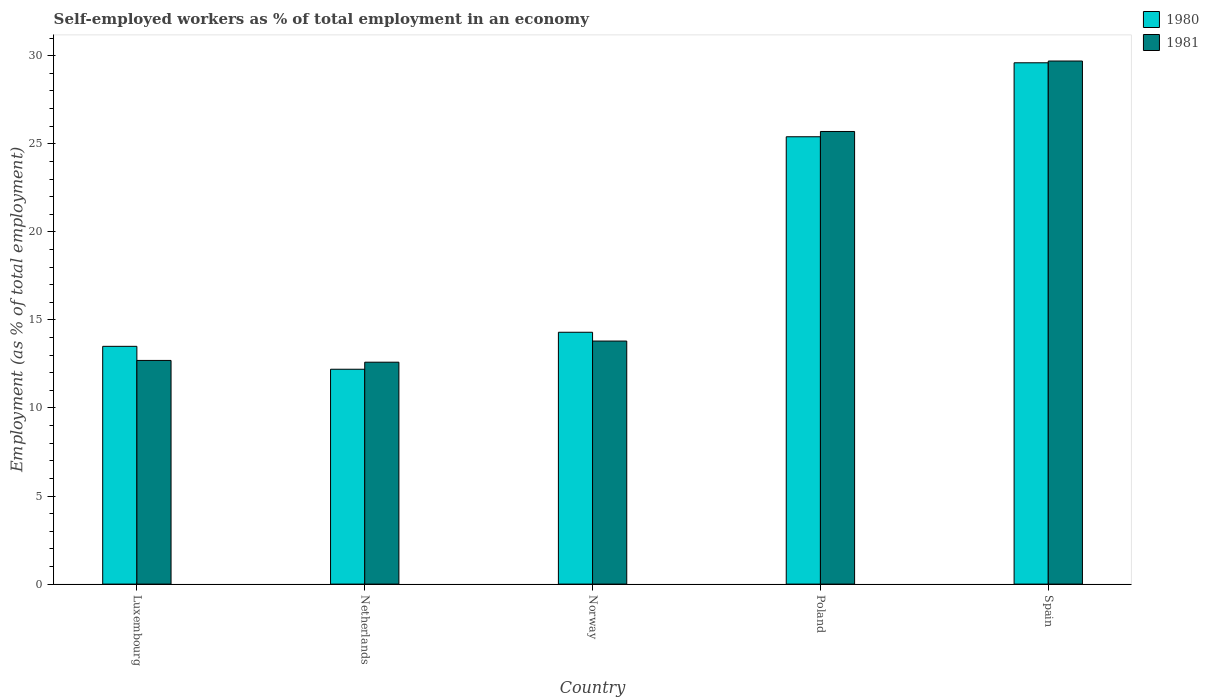How many groups of bars are there?
Your response must be concise. 5. Are the number of bars per tick equal to the number of legend labels?
Offer a terse response. Yes. How many bars are there on the 5th tick from the right?
Your answer should be compact. 2. What is the label of the 5th group of bars from the left?
Make the answer very short. Spain. What is the percentage of self-employed workers in 1981 in Netherlands?
Your response must be concise. 12.6. Across all countries, what is the maximum percentage of self-employed workers in 1980?
Your response must be concise. 29.6. Across all countries, what is the minimum percentage of self-employed workers in 1980?
Offer a very short reply. 12.2. In which country was the percentage of self-employed workers in 1981 maximum?
Provide a short and direct response. Spain. What is the total percentage of self-employed workers in 1980 in the graph?
Your response must be concise. 95. What is the difference between the percentage of self-employed workers in 1980 in Netherlands and that in Poland?
Your answer should be compact. -13.2. What is the difference between the percentage of self-employed workers in 1980 in Netherlands and the percentage of self-employed workers in 1981 in Norway?
Offer a terse response. -1.6. What is the difference between the percentage of self-employed workers of/in 1981 and percentage of self-employed workers of/in 1980 in Spain?
Offer a very short reply. 0.1. What is the ratio of the percentage of self-employed workers in 1981 in Norway to that in Spain?
Your response must be concise. 0.46. What is the difference between the highest and the second highest percentage of self-employed workers in 1980?
Provide a succinct answer. -4.2. What is the difference between the highest and the lowest percentage of self-employed workers in 1981?
Ensure brevity in your answer.  17.1. What does the 1st bar from the left in Luxembourg represents?
Provide a short and direct response. 1980. How many countries are there in the graph?
Provide a short and direct response. 5. What is the difference between two consecutive major ticks on the Y-axis?
Make the answer very short. 5. Are the values on the major ticks of Y-axis written in scientific E-notation?
Give a very brief answer. No. Where does the legend appear in the graph?
Offer a terse response. Top right. How many legend labels are there?
Provide a succinct answer. 2. How are the legend labels stacked?
Make the answer very short. Vertical. What is the title of the graph?
Offer a very short reply. Self-employed workers as % of total employment in an economy. What is the label or title of the X-axis?
Offer a very short reply. Country. What is the label or title of the Y-axis?
Keep it short and to the point. Employment (as % of total employment). What is the Employment (as % of total employment) in 1981 in Luxembourg?
Provide a succinct answer. 12.7. What is the Employment (as % of total employment) of 1980 in Netherlands?
Give a very brief answer. 12.2. What is the Employment (as % of total employment) in 1981 in Netherlands?
Keep it short and to the point. 12.6. What is the Employment (as % of total employment) in 1980 in Norway?
Your response must be concise. 14.3. What is the Employment (as % of total employment) in 1981 in Norway?
Make the answer very short. 13.8. What is the Employment (as % of total employment) of 1980 in Poland?
Offer a very short reply. 25.4. What is the Employment (as % of total employment) of 1981 in Poland?
Keep it short and to the point. 25.7. What is the Employment (as % of total employment) of 1980 in Spain?
Keep it short and to the point. 29.6. What is the Employment (as % of total employment) in 1981 in Spain?
Ensure brevity in your answer.  29.7. Across all countries, what is the maximum Employment (as % of total employment) in 1980?
Give a very brief answer. 29.6. Across all countries, what is the maximum Employment (as % of total employment) of 1981?
Offer a terse response. 29.7. Across all countries, what is the minimum Employment (as % of total employment) of 1980?
Make the answer very short. 12.2. Across all countries, what is the minimum Employment (as % of total employment) in 1981?
Provide a succinct answer. 12.6. What is the total Employment (as % of total employment) of 1981 in the graph?
Provide a short and direct response. 94.5. What is the difference between the Employment (as % of total employment) in 1981 in Luxembourg and that in Netherlands?
Give a very brief answer. 0.1. What is the difference between the Employment (as % of total employment) of 1980 in Luxembourg and that in Norway?
Provide a short and direct response. -0.8. What is the difference between the Employment (as % of total employment) of 1980 in Luxembourg and that in Spain?
Provide a short and direct response. -16.1. What is the difference between the Employment (as % of total employment) of 1981 in Luxembourg and that in Spain?
Your answer should be compact. -17. What is the difference between the Employment (as % of total employment) in 1980 in Netherlands and that in Poland?
Keep it short and to the point. -13.2. What is the difference between the Employment (as % of total employment) in 1980 in Netherlands and that in Spain?
Your answer should be compact. -17.4. What is the difference between the Employment (as % of total employment) in 1981 in Netherlands and that in Spain?
Give a very brief answer. -17.1. What is the difference between the Employment (as % of total employment) in 1980 in Norway and that in Poland?
Offer a terse response. -11.1. What is the difference between the Employment (as % of total employment) in 1980 in Norway and that in Spain?
Your response must be concise. -15.3. What is the difference between the Employment (as % of total employment) in 1981 in Norway and that in Spain?
Provide a succinct answer. -15.9. What is the difference between the Employment (as % of total employment) in 1981 in Poland and that in Spain?
Your response must be concise. -4. What is the difference between the Employment (as % of total employment) in 1980 in Luxembourg and the Employment (as % of total employment) in 1981 in Netherlands?
Ensure brevity in your answer.  0.9. What is the difference between the Employment (as % of total employment) in 1980 in Luxembourg and the Employment (as % of total employment) in 1981 in Norway?
Offer a terse response. -0.3. What is the difference between the Employment (as % of total employment) in 1980 in Luxembourg and the Employment (as % of total employment) in 1981 in Poland?
Your answer should be very brief. -12.2. What is the difference between the Employment (as % of total employment) in 1980 in Luxembourg and the Employment (as % of total employment) in 1981 in Spain?
Your answer should be very brief. -16.2. What is the difference between the Employment (as % of total employment) in 1980 in Netherlands and the Employment (as % of total employment) in 1981 in Poland?
Your answer should be very brief. -13.5. What is the difference between the Employment (as % of total employment) in 1980 in Netherlands and the Employment (as % of total employment) in 1981 in Spain?
Provide a succinct answer. -17.5. What is the difference between the Employment (as % of total employment) of 1980 in Norway and the Employment (as % of total employment) of 1981 in Poland?
Make the answer very short. -11.4. What is the difference between the Employment (as % of total employment) in 1980 in Norway and the Employment (as % of total employment) in 1981 in Spain?
Offer a terse response. -15.4. What is the difference between the Employment (as % of total employment) in 1980 and Employment (as % of total employment) in 1981 in Norway?
Your answer should be compact. 0.5. What is the ratio of the Employment (as % of total employment) of 1980 in Luxembourg to that in Netherlands?
Keep it short and to the point. 1.11. What is the ratio of the Employment (as % of total employment) of 1981 in Luxembourg to that in Netherlands?
Give a very brief answer. 1.01. What is the ratio of the Employment (as % of total employment) in 1980 in Luxembourg to that in Norway?
Your answer should be compact. 0.94. What is the ratio of the Employment (as % of total employment) in 1981 in Luxembourg to that in Norway?
Your answer should be compact. 0.92. What is the ratio of the Employment (as % of total employment) of 1980 in Luxembourg to that in Poland?
Your response must be concise. 0.53. What is the ratio of the Employment (as % of total employment) of 1981 in Luxembourg to that in Poland?
Make the answer very short. 0.49. What is the ratio of the Employment (as % of total employment) of 1980 in Luxembourg to that in Spain?
Your answer should be very brief. 0.46. What is the ratio of the Employment (as % of total employment) in 1981 in Luxembourg to that in Spain?
Your answer should be compact. 0.43. What is the ratio of the Employment (as % of total employment) of 1980 in Netherlands to that in Norway?
Offer a very short reply. 0.85. What is the ratio of the Employment (as % of total employment) in 1981 in Netherlands to that in Norway?
Give a very brief answer. 0.91. What is the ratio of the Employment (as % of total employment) of 1980 in Netherlands to that in Poland?
Give a very brief answer. 0.48. What is the ratio of the Employment (as % of total employment) of 1981 in Netherlands to that in Poland?
Make the answer very short. 0.49. What is the ratio of the Employment (as % of total employment) in 1980 in Netherlands to that in Spain?
Ensure brevity in your answer.  0.41. What is the ratio of the Employment (as % of total employment) of 1981 in Netherlands to that in Spain?
Provide a succinct answer. 0.42. What is the ratio of the Employment (as % of total employment) in 1980 in Norway to that in Poland?
Keep it short and to the point. 0.56. What is the ratio of the Employment (as % of total employment) in 1981 in Norway to that in Poland?
Provide a succinct answer. 0.54. What is the ratio of the Employment (as % of total employment) of 1980 in Norway to that in Spain?
Provide a succinct answer. 0.48. What is the ratio of the Employment (as % of total employment) in 1981 in Norway to that in Spain?
Your answer should be very brief. 0.46. What is the ratio of the Employment (as % of total employment) in 1980 in Poland to that in Spain?
Ensure brevity in your answer.  0.86. What is the ratio of the Employment (as % of total employment) of 1981 in Poland to that in Spain?
Keep it short and to the point. 0.87. What is the difference between the highest and the second highest Employment (as % of total employment) in 1980?
Ensure brevity in your answer.  4.2. What is the difference between the highest and the lowest Employment (as % of total employment) of 1980?
Provide a short and direct response. 17.4. 